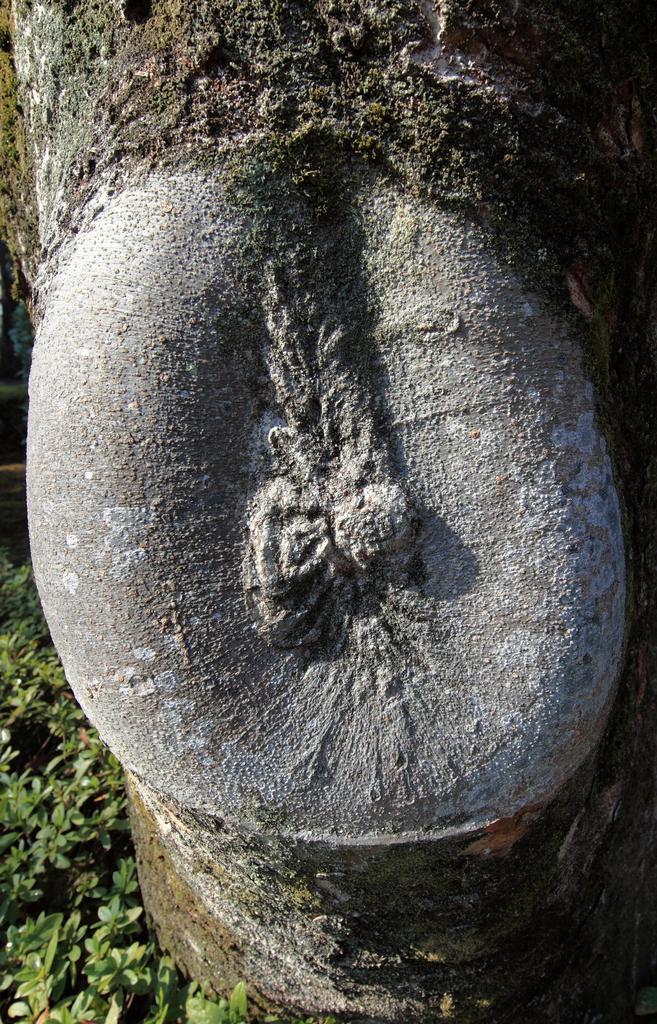In one or two sentences, can you explain what this image depicts? In this image, we can see the tree trunk. On the left side bottom corner, we can see few plants. 